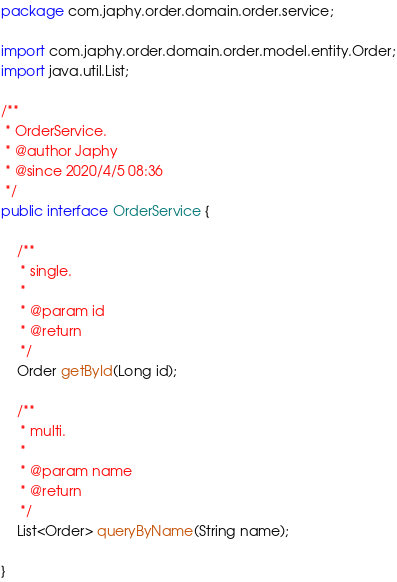<code> <loc_0><loc_0><loc_500><loc_500><_Java_>package com.japhy.order.domain.order.service;

import com.japhy.order.domain.order.model.entity.Order;
import java.util.List;

/**
 * OrderService.
 * @author Japhy
 * @since 2020/4/5 08:36
 */
public interface OrderService {

    /**
     * single.
     *
     * @param id
     * @return
     */
    Order getById(Long id);

    /**
     * multi.
     *
     * @param name
     * @return
     */
    List<Order> queryByName(String name);

}
</code> 